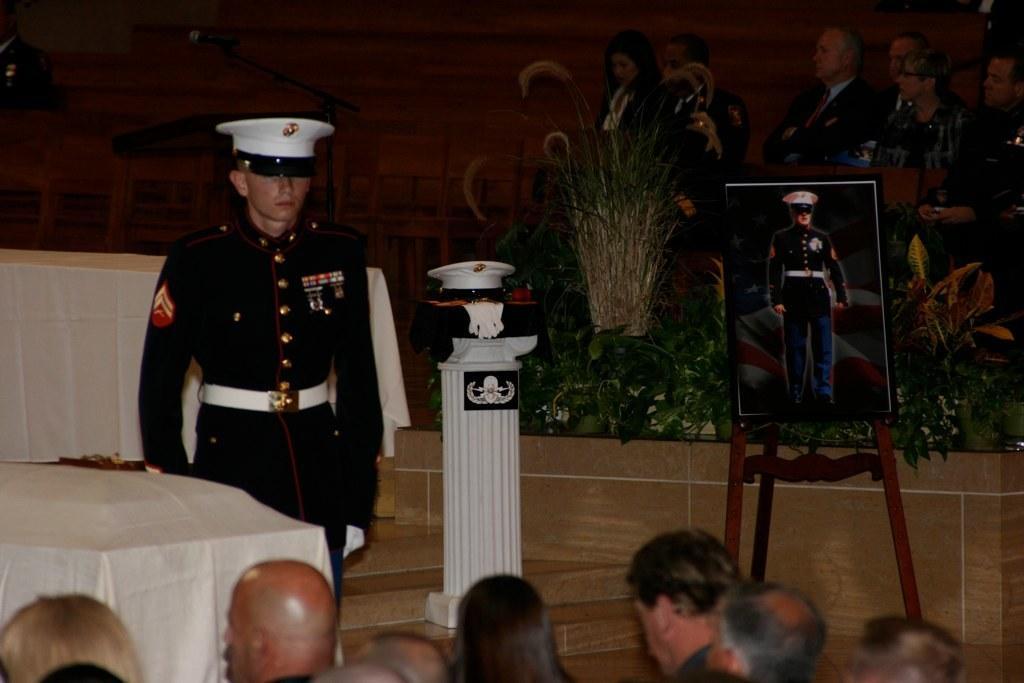Can you describe this image briefly? In this image at the bottom, there are many people. In the middle there is a man, he wears a shirt, trouser, cap. On the right there is a photo frame, chair, plants. In the middle there is a cap, fire, pillar. 